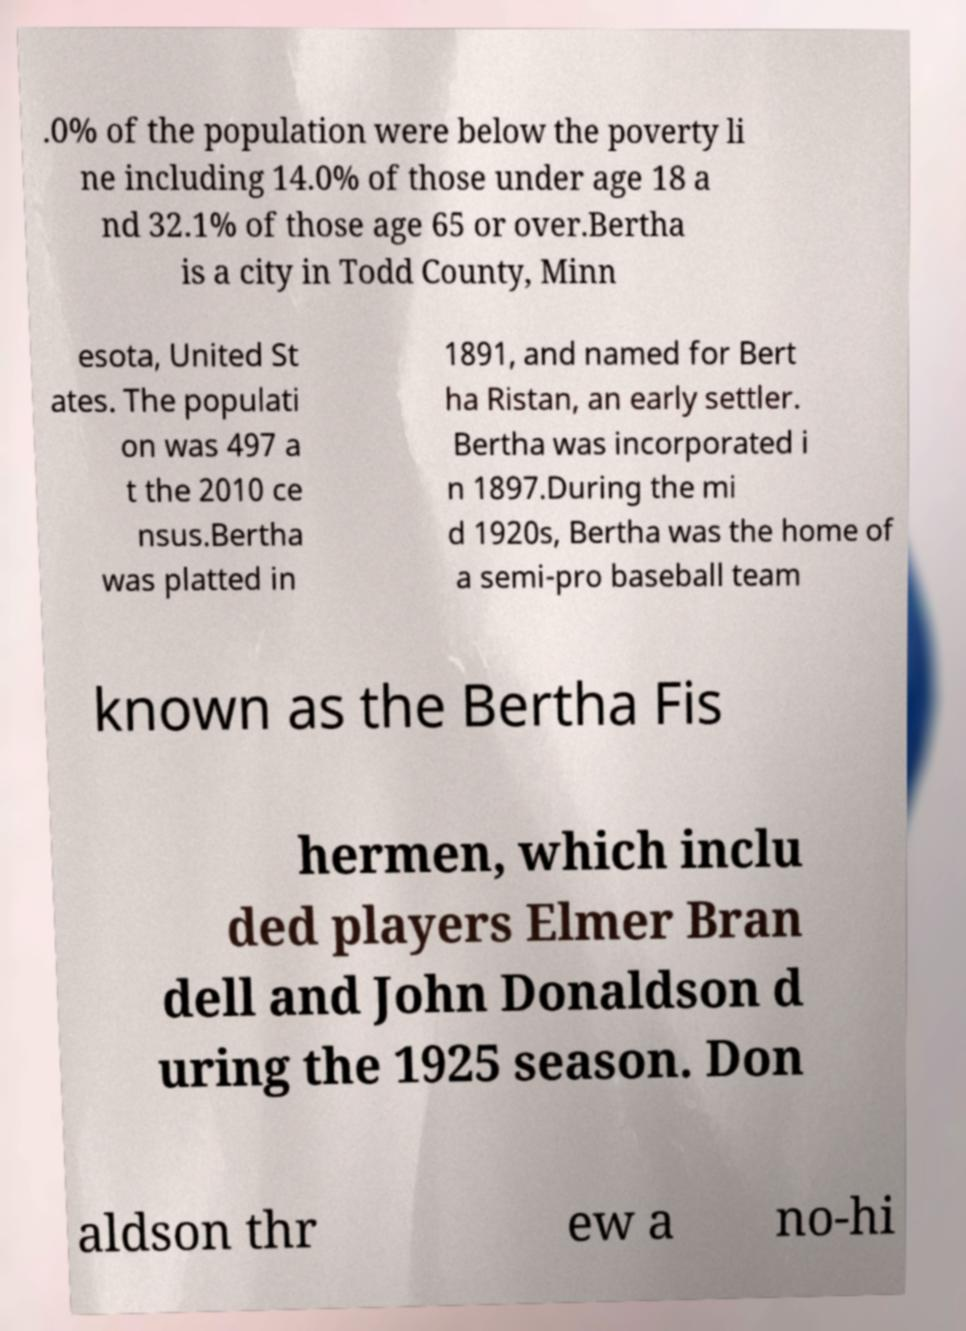Can you accurately transcribe the text from the provided image for me? .0% of the population were below the poverty li ne including 14.0% of those under age 18 a nd 32.1% of those age 65 or over.Bertha is a city in Todd County, Minn esota, United St ates. The populati on was 497 a t the 2010 ce nsus.Bertha was platted in 1891, and named for Bert ha Ristan, an early settler. Bertha was incorporated i n 1897.During the mi d 1920s, Bertha was the home of a semi-pro baseball team known as the Bertha Fis hermen, which inclu ded players Elmer Bran dell and John Donaldson d uring the 1925 season. Don aldson thr ew a no-hi 